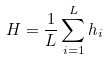Convert formula to latex. <formula><loc_0><loc_0><loc_500><loc_500>H = \frac { 1 } { L } \sum _ { i = 1 } ^ { L } h _ { i }</formula> 